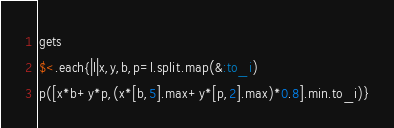<code> <loc_0><loc_0><loc_500><loc_500><_Ruby_>gets
$<.each{|l|x,y,b,p=l.split.map(&:to_i)
p([x*b+y*p,(x*[b,5].max+y*[p,2].max)*0.8].min.to_i)}</code> 